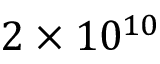Convert formula to latex. <formula><loc_0><loc_0><loc_500><loc_500>2 \times 1 0 ^ { 1 0 }</formula> 